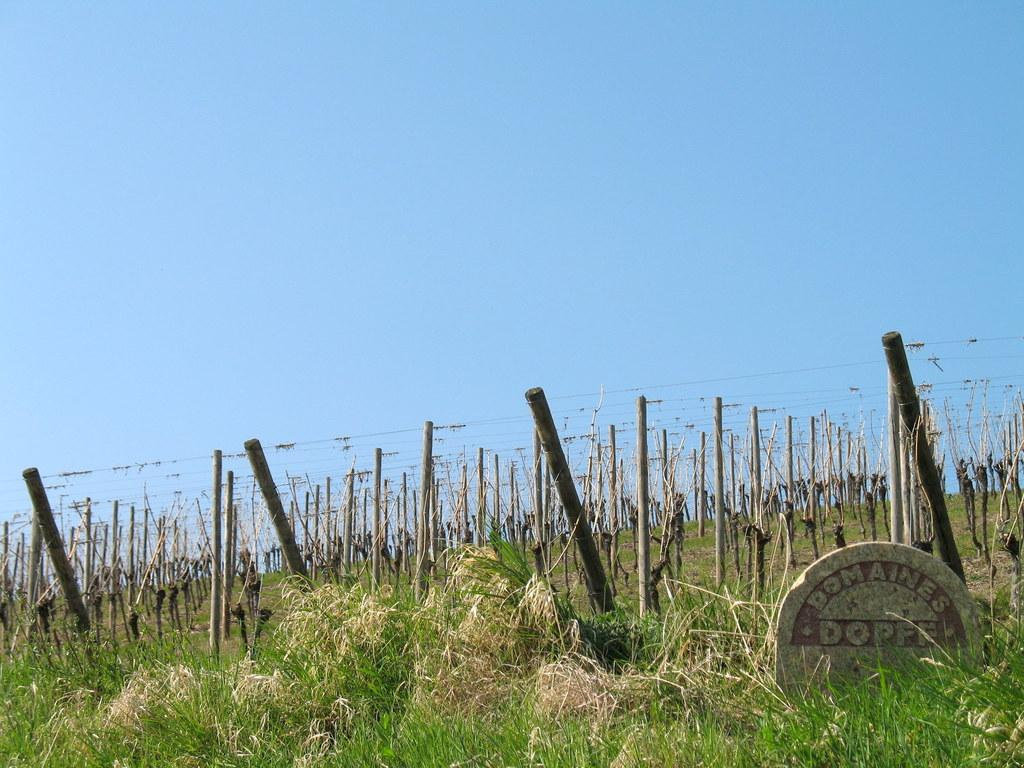What type of vegetation can be seen in the image? There are plants in the image. What is covering the ground in the image? There is grass on the ground in the image. What structures are present on the ground in the image? There are poles on the ground in the image. What is the condition of the sky in the image? The sky is clear in the image. How many rings are visible on the plants in the image? There are no rings present on the plants in the image. What type of trains can be seen passing by in the image? There are no trains present in the image. 